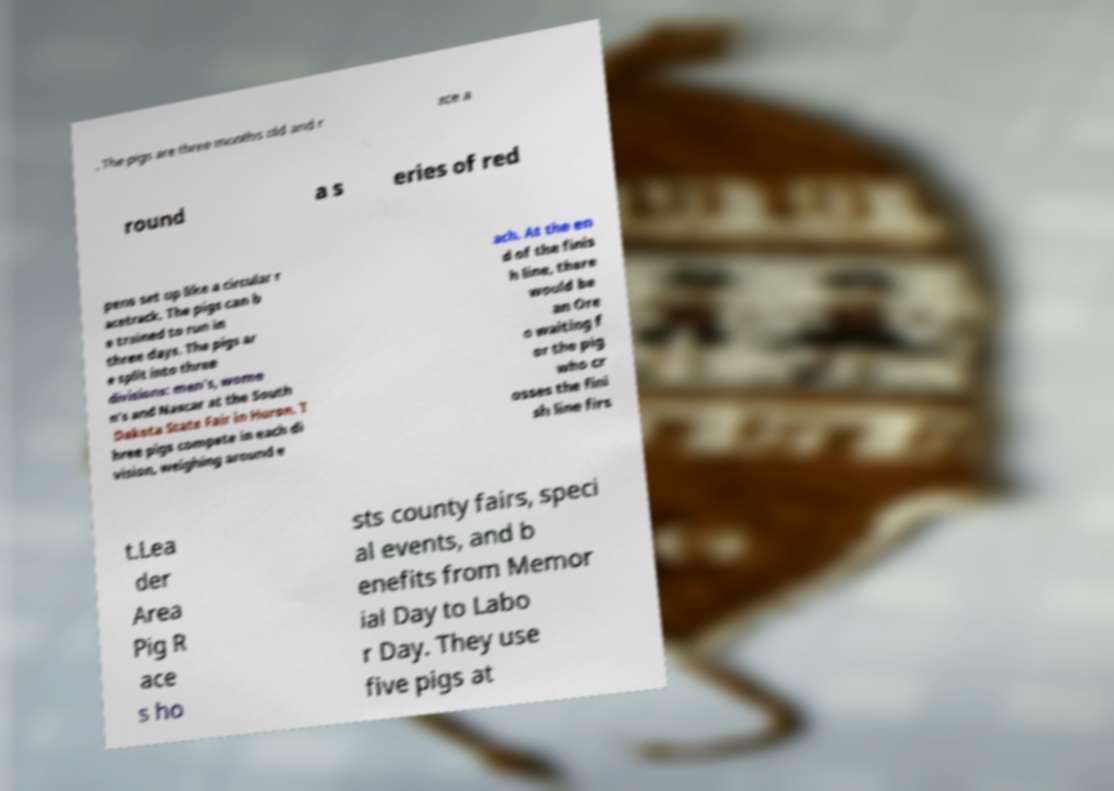I need the written content from this picture converted into text. Can you do that? . The pigs are three months old and r ace a round a s eries of red pens set up like a circular r acetrack. The pigs can b e trained to run in three days. The pigs ar e split into three divisions: men's, wome n's and Nascar at the South Dakota State Fair in Huron. T hree pigs compete in each di vision, weighing around e ach. At the en d of the finis h line, there would be an Ore o waiting f or the pig who cr osses the fini sh line firs t.Lea der Area Pig R ace s ho sts county fairs, speci al events, and b enefits from Memor ial Day to Labo r Day. They use five pigs at 